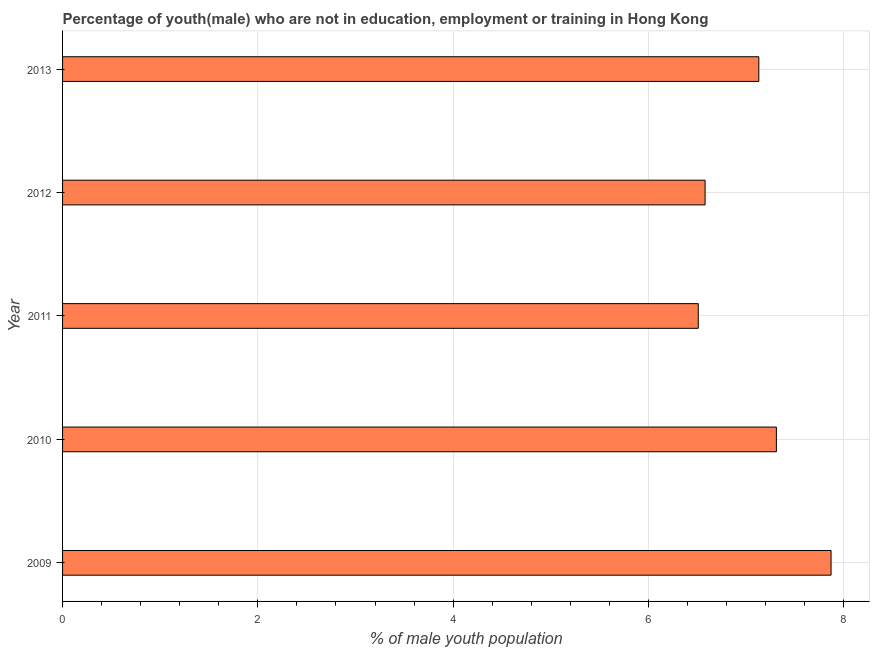Does the graph contain grids?
Ensure brevity in your answer.  Yes. What is the title of the graph?
Your response must be concise. Percentage of youth(male) who are not in education, employment or training in Hong Kong. What is the label or title of the X-axis?
Your answer should be very brief. % of male youth population. What is the unemployed male youth population in 2013?
Your response must be concise. 7.13. Across all years, what is the maximum unemployed male youth population?
Offer a terse response. 7.87. Across all years, what is the minimum unemployed male youth population?
Give a very brief answer. 6.51. In which year was the unemployed male youth population minimum?
Provide a short and direct response. 2011. What is the sum of the unemployed male youth population?
Offer a very short reply. 35.4. What is the difference between the unemployed male youth population in 2009 and 2011?
Provide a succinct answer. 1.36. What is the average unemployed male youth population per year?
Provide a short and direct response. 7.08. What is the median unemployed male youth population?
Provide a succinct answer. 7.13. In how many years, is the unemployed male youth population greater than 7.6 %?
Ensure brevity in your answer.  1. Do a majority of the years between 2009 and 2010 (inclusive) have unemployed male youth population greater than 0.8 %?
Provide a short and direct response. Yes. What is the ratio of the unemployed male youth population in 2012 to that in 2013?
Provide a short and direct response. 0.92. Is the unemployed male youth population in 2011 less than that in 2013?
Offer a terse response. Yes. Is the difference between the unemployed male youth population in 2009 and 2011 greater than the difference between any two years?
Provide a short and direct response. Yes. What is the difference between the highest and the second highest unemployed male youth population?
Your answer should be very brief. 0.56. Is the sum of the unemployed male youth population in 2010 and 2012 greater than the maximum unemployed male youth population across all years?
Your answer should be very brief. Yes. What is the difference between the highest and the lowest unemployed male youth population?
Your response must be concise. 1.36. In how many years, is the unemployed male youth population greater than the average unemployed male youth population taken over all years?
Your answer should be very brief. 3. Are the values on the major ticks of X-axis written in scientific E-notation?
Your answer should be very brief. No. What is the % of male youth population of 2009?
Keep it short and to the point. 7.87. What is the % of male youth population of 2010?
Your response must be concise. 7.31. What is the % of male youth population of 2011?
Provide a short and direct response. 6.51. What is the % of male youth population in 2012?
Provide a short and direct response. 6.58. What is the % of male youth population in 2013?
Ensure brevity in your answer.  7.13. What is the difference between the % of male youth population in 2009 and 2010?
Provide a succinct answer. 0.56. What is the difference between the % of male youth population in 2009 and 2011?
Make the answer very short. 1.36. What is the difference between the % of male youth population in 2009 and 2012?
Offer a very short reply. 1.29. What is the difference between the % of male youth population in 2009 and 2013?
Provide a succinct answer. 0.74. What is the difference between the % of male youth population in 2010 and 2012?
Offer a very short reply. 0.73. What is the difference between the % of male youth population in 2010 and 2013?
Give a very brief answer. 0.18. What is the difference between the % of male youth population in 2011 and 2012?
Your response must be concise. -0.07. What is the difference between the % of male youth population in 2011 and 2013?
Make the answer very short. -0.62. What is the difference between the % of male youth population in 2012 and 2013?
Your answer should be very brief. -0.55. What is the ratio of the % of male youth population in 2009 to that in 2010?
Give a very brief answer. 1.08. What is the ratio of the % of male youth population in 2009 to that in 2011?
Your response must be concise. 1.21. What is the ratio of the % of male youth population in 2009 to that in 2012?
Your response must be concise. 1.2. What is the ratio of the % of male youth population in 2009 to that in 2013?
Offer a very short reply. 1.1. What is the ratio of the % of male youth population in 2010 to that in 2011?
Keep it short and to the point. 1.12. What is the ratio of the % of male youth population in 2010 to that in 2012?
Provide a succinct answer. 1.11. What is the ratio of the % of male youth population in 2011 to that in 2012?
Your answer should be compact. 0.99. What is the ratio of the % of male youth population in 2012 to that in 2013?
Keep it short and to the point. 0.92. 